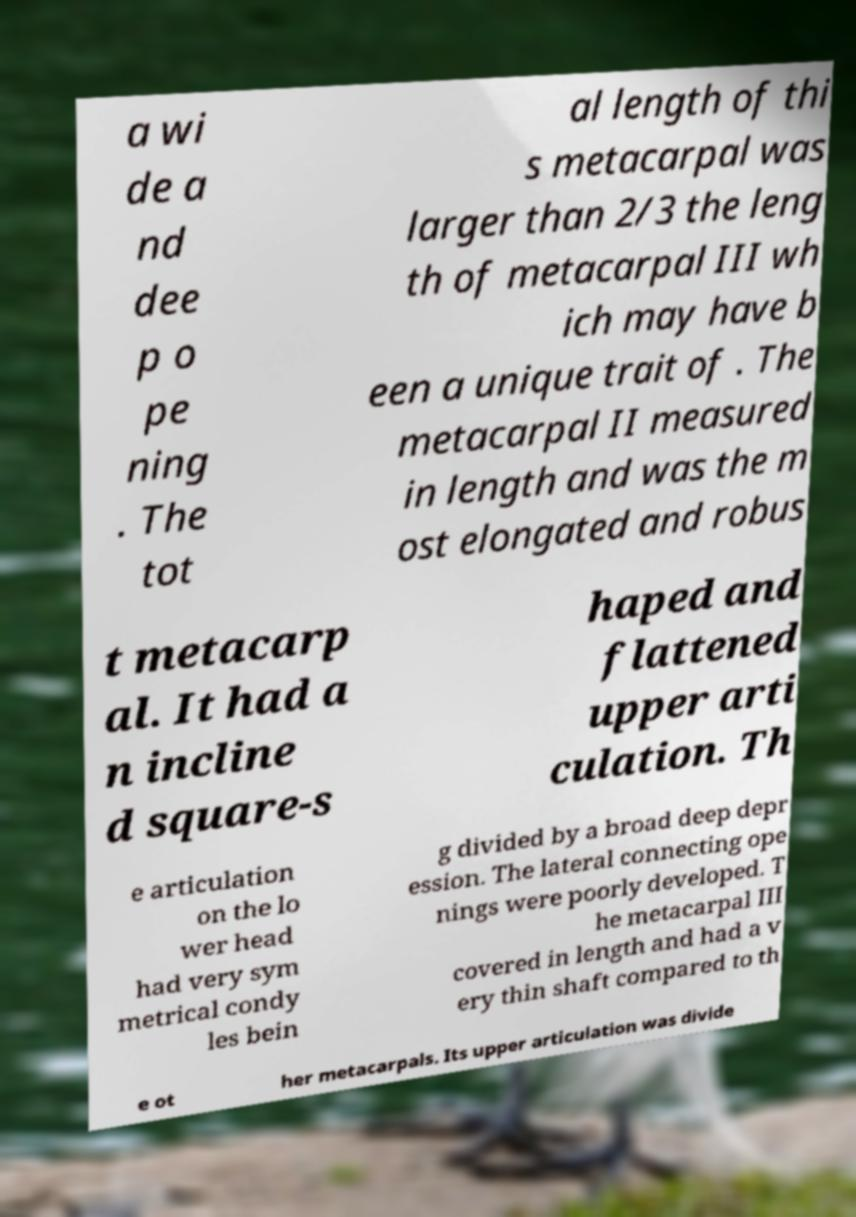Could you assist in decoding the text presented in this image and type it out clearly? a wi de a nd dee p o pe ning . The tot al length of thi s metacarpal was larger than 2/3 the leng th of metacarpal III wh ich may have b een a unique trait of . The metacarpal II measured in length and was the m ost elongated and robus t metacarp al. It had a n incline d square-s haped and flattened upper arti culation. Th e articulation on the lo wer head had very sym metrical condy les bein g divided by a broad deep depr ession. The lateral connecting ope nings were poorly developed. T he metacarpal III covered in length and had a v ery thin shaft compared to th e ot her metacarpals. Its upper articulation was divide 